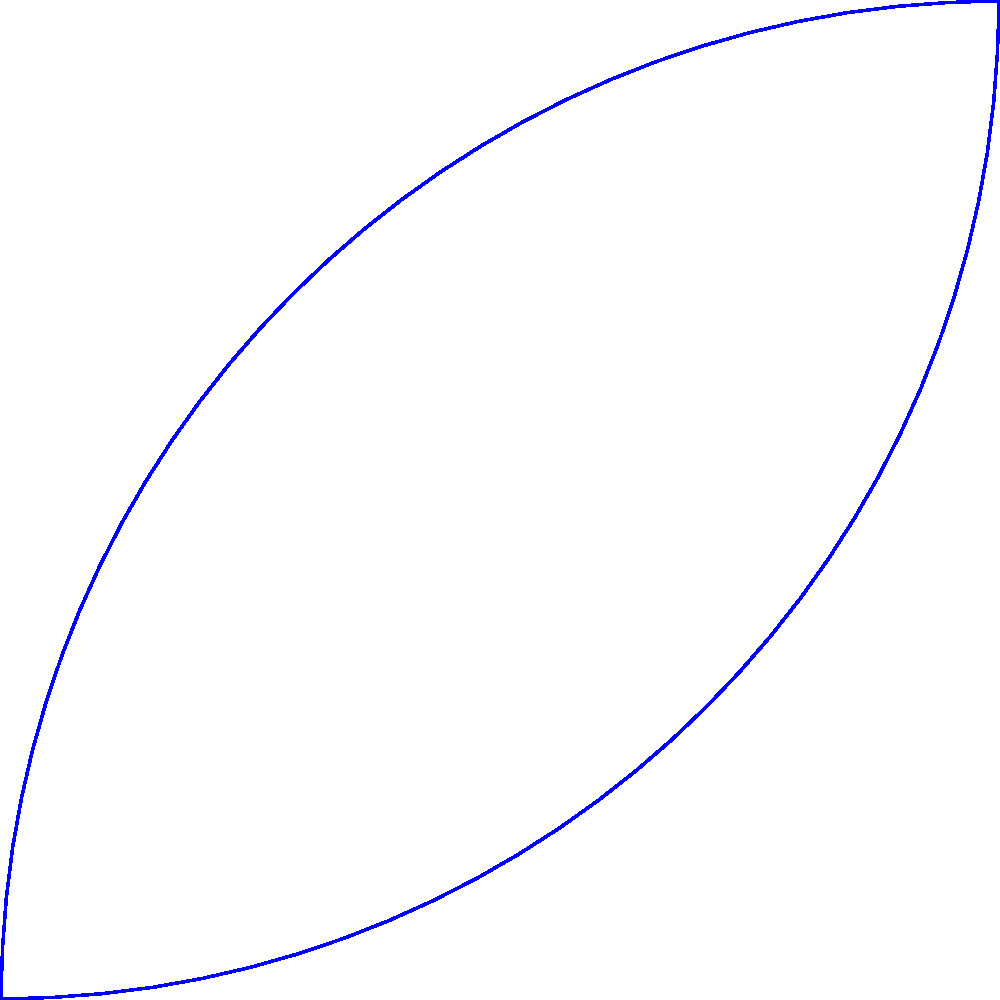In the context of celestial bodies that bring new life to the universe, much like how organ donation brings new life to recipients, can you identify the three main types of galaxies shown in the image above? 1. The blue shape on the left represents a spiral galaxy. These galaxies have a distinctive spiral arm structure, often containing younger stars and active star formation regions. The spiral arms wrap around a central bulge, similar to how a heart's chambers work together to sustain life.

2. The red shape in the middle represents an elliptical galaxy. These galaxies are generally smoother and more uniform in appearance, lacking the spiral arm structure. They are often composed of older stars and have less ongoing star formation, reminiscent of the wisdom and experience that comes with age.

3. The green shape on the right represents an irregular galaxy. These galaxies have no definite shape or structure, often resulting from galactic collisions or interactions. Their chaotic nature can be seen as a metaphor for the unexpected twists and turns in life, including the difficult decisions we sometimes face.

Each type of galaxy contributes to the diversity and beauty of the universe, much like how each person's life and choices can have a profound impact on others.
Answer: Spiral, elliptical, and irregular galaxies 